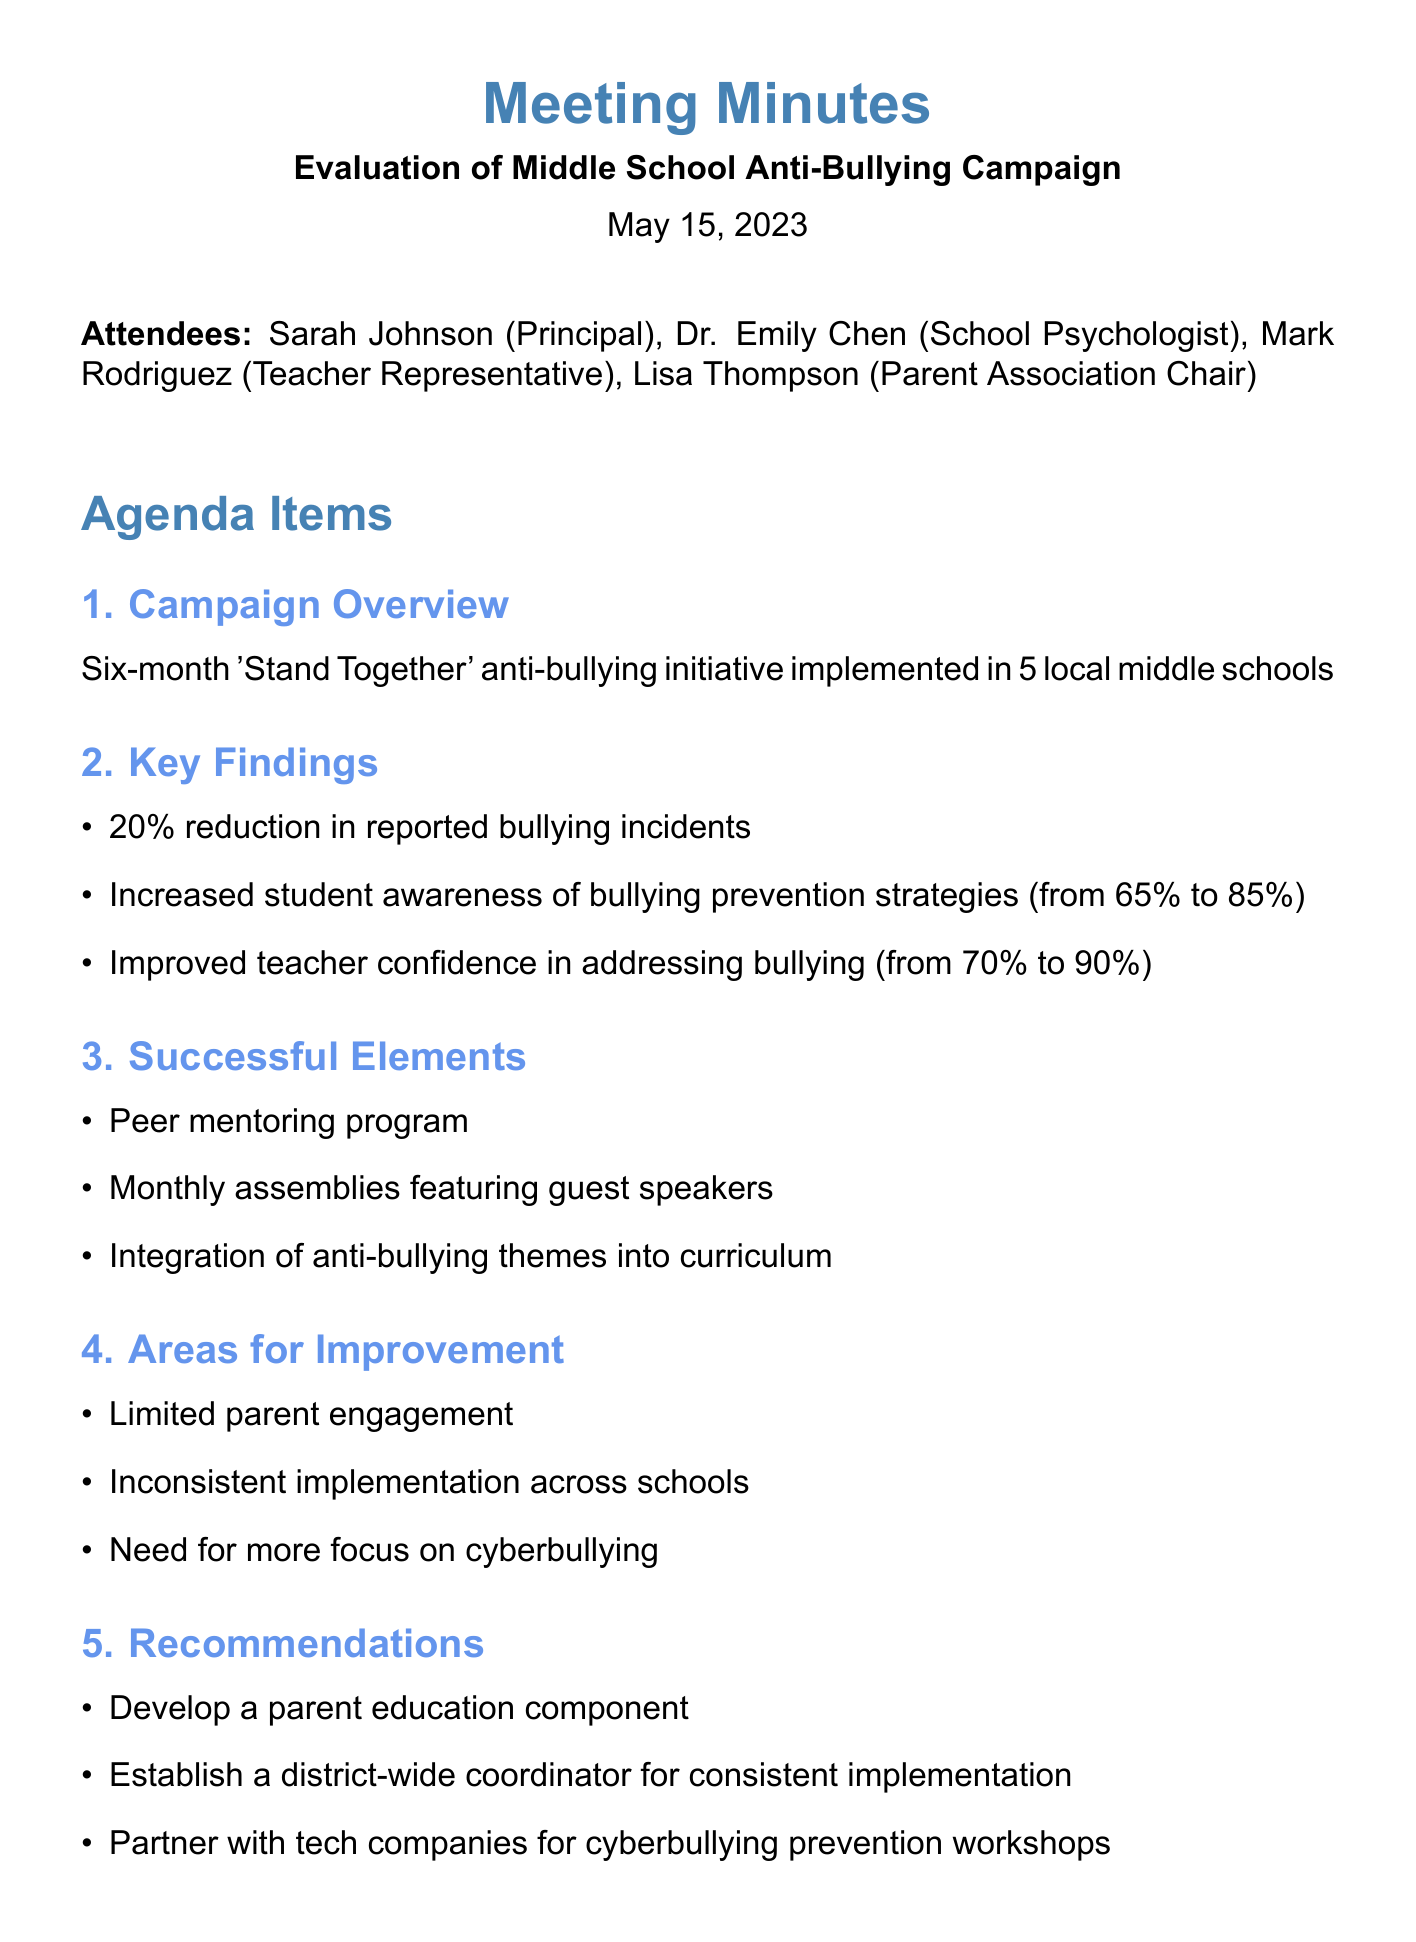What is the title of the meeting? The title is stated at the beginning of the document under "Evaluation of Middle School Anti-Bullying Campaign."
Answer: Evaluation of Middle School Anti-Bullying Campaign When was the meeting held? The date is mentioned in the header of the meeting minutes.
Answer: May 15, 2023 How many middle schools participated in the initiative? The document specifies that the anti-bullying initiative was implemented in 5 middle schools.
Answer: 5 What percentage reduction in reported bullying incidents was noted? The key findings section lists a 20% reduction in reported bullying incidents.
Answer: 20% What was one successful element of the campaign? The successful elements section mentions several components; one is the peer mentoring program.
Answer: Peer mentoring program What is one area for improvement identified in the meeting? The document lists areas for improvement, one of which is limited parent engagement.
Answer: Limited parent engagement What is the next step scheduled for June 1st? The next step involves presenting findings to the school board as outlined in the document.
Answer: Present findings to school board Who is responsible for developing a parent education component? The document recommends developing a parent education component without specifying an individual.
Answer: Not specified What percentage of students increased their awareness of bullying prevention strategies? The document shows an increase in awareness from 65% to 85%.
Answer: From 65% to 85% 